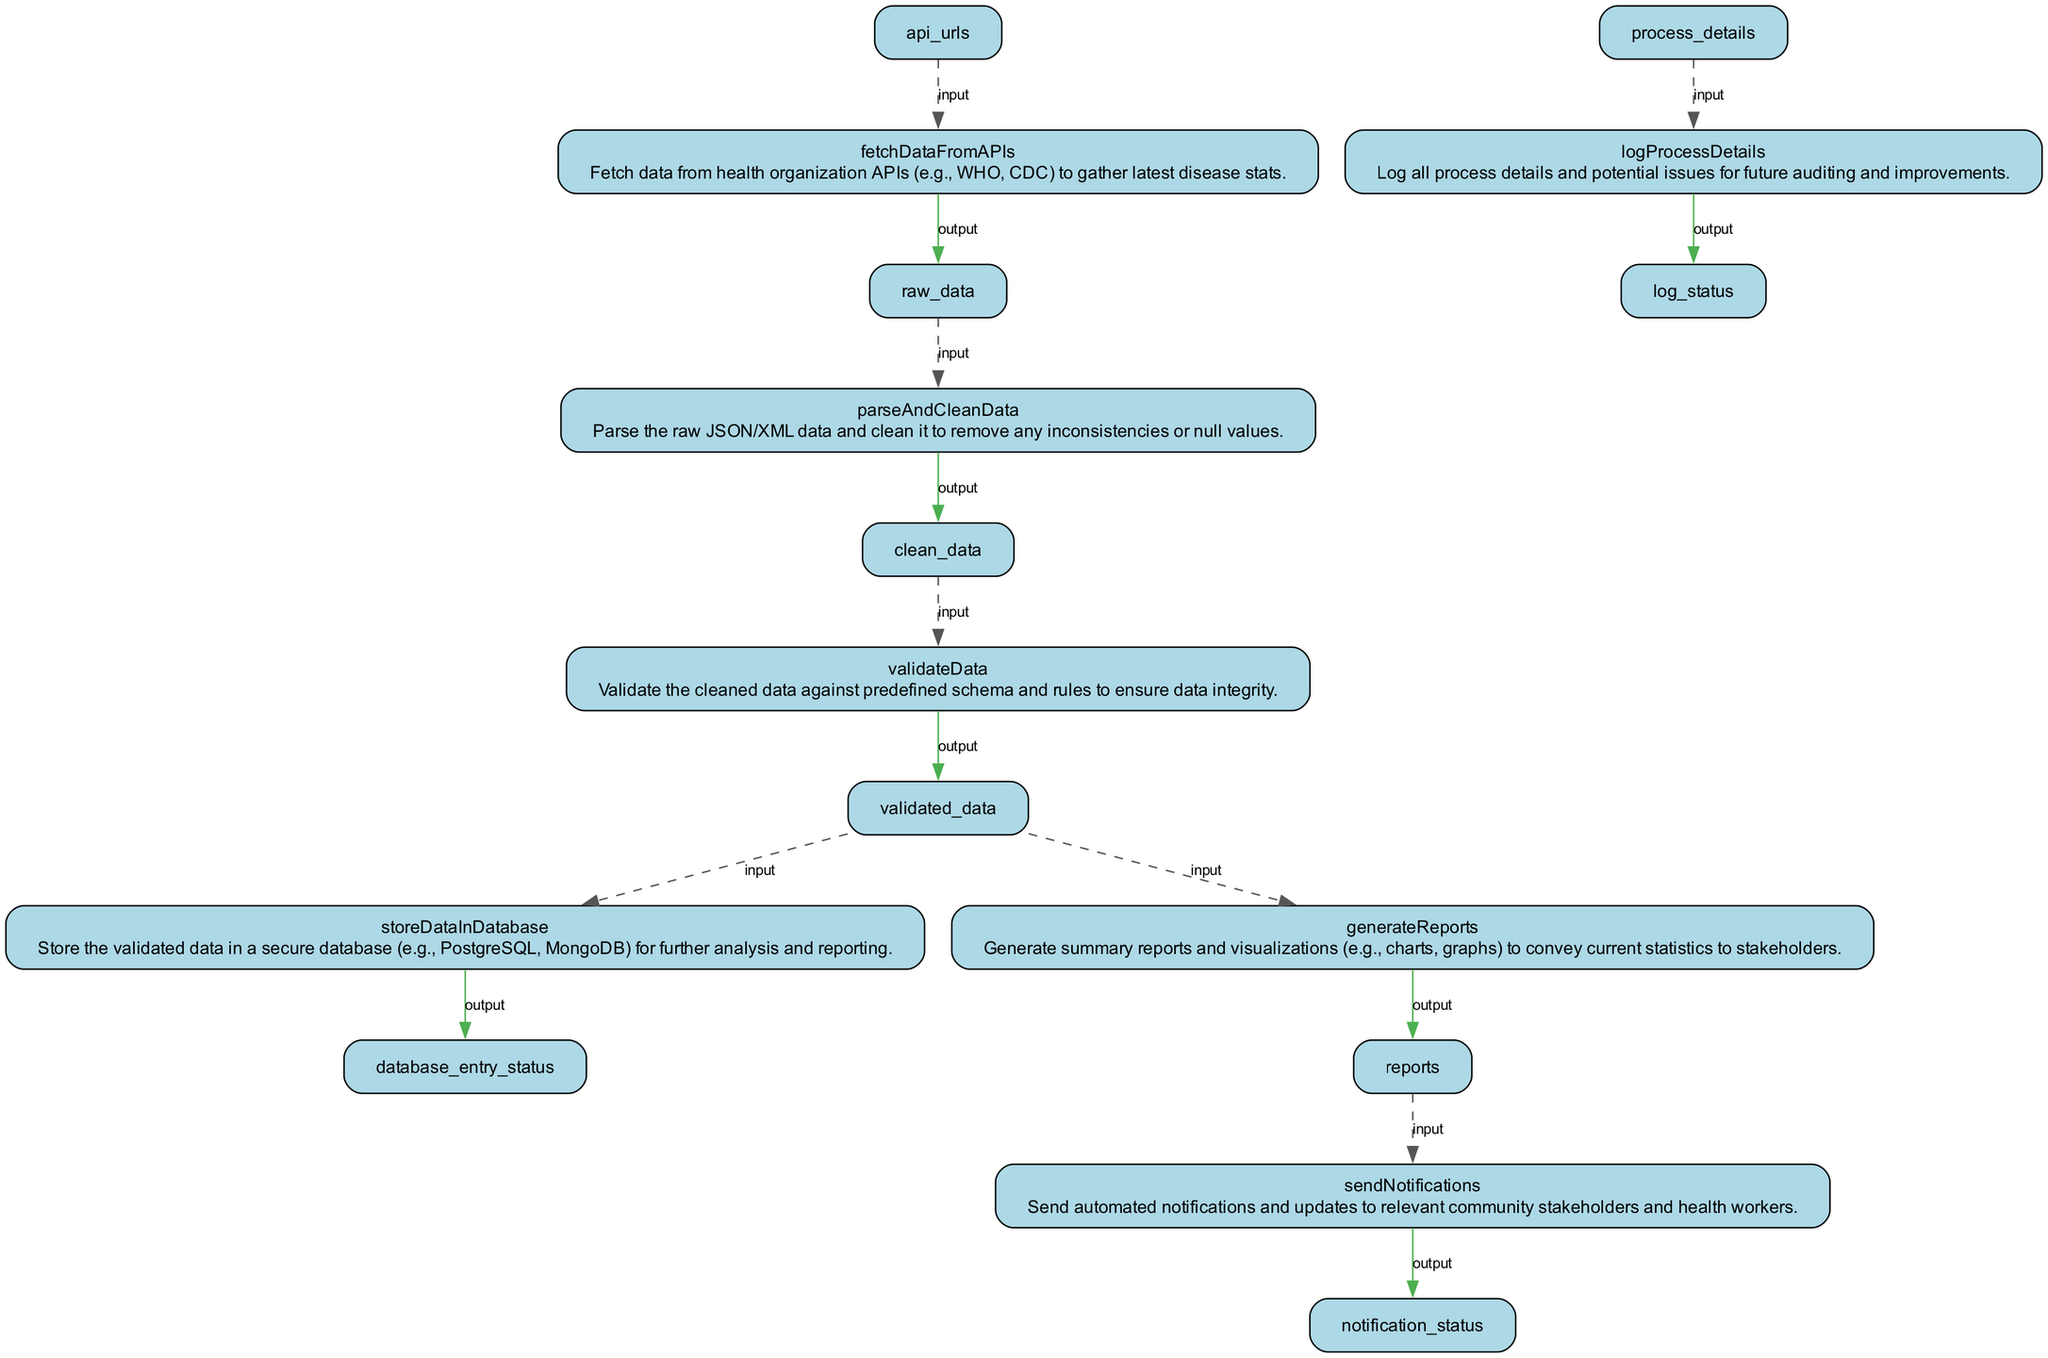What is the first node in the flowchart? The first node in the flowchart is labeled 'fetchDataFromAPIs', which indicates it is the initial step in the process of tracking and reporting disease cases.
Answer: fetchDataFromAPIs How many outputs are generated by the 'storeDataInDatabase' node? The 'storeDataInDatabase' node produces one output, which is 'database_entry_status', as indicated in the diagram.
Answer: one What is the output of the 'validateData' node? The output of the 'validateData' node is 'validated_data', as listed in the outputs section of the node in the diagram.
Answer: validated_data Which node sends notifications? The node responsible for sending notifications is 'sendNotifications', as indicated by its name in the diagram.
Answer: sendNotifications What is the relationship between 'parseAndCleanData' and 'validateData'? The relationship is that 'parseAndCleanData' outputs 'clean_data', which serves as an input for 'validateData', forming a direct link in the flowchart process.
Answer: clean_data What step follows the 'fetchDataFromAPIs' node? The step that follows the 'fetchDataFromAPIs' node is 'parseAndCleanData', indicating the next action taken after fetching data.
Answer: parseAndCleanData How many nodes exist in the flowchart? There are a total of seven nodes in the flowchart, each representing a step in the disease tracking process.
Answer: seven Which node is responsible for generating reports? The node responsible for generating reports is 'generateReports', which is specifically designed for this function according to the diagram.
Answer: generateReports What does the 'logProcessDetails' node output? The 'logProcessDetails' node outputs 'log_status', which signifies the result of logging the process details in the flowchart.
Answer: log_status 